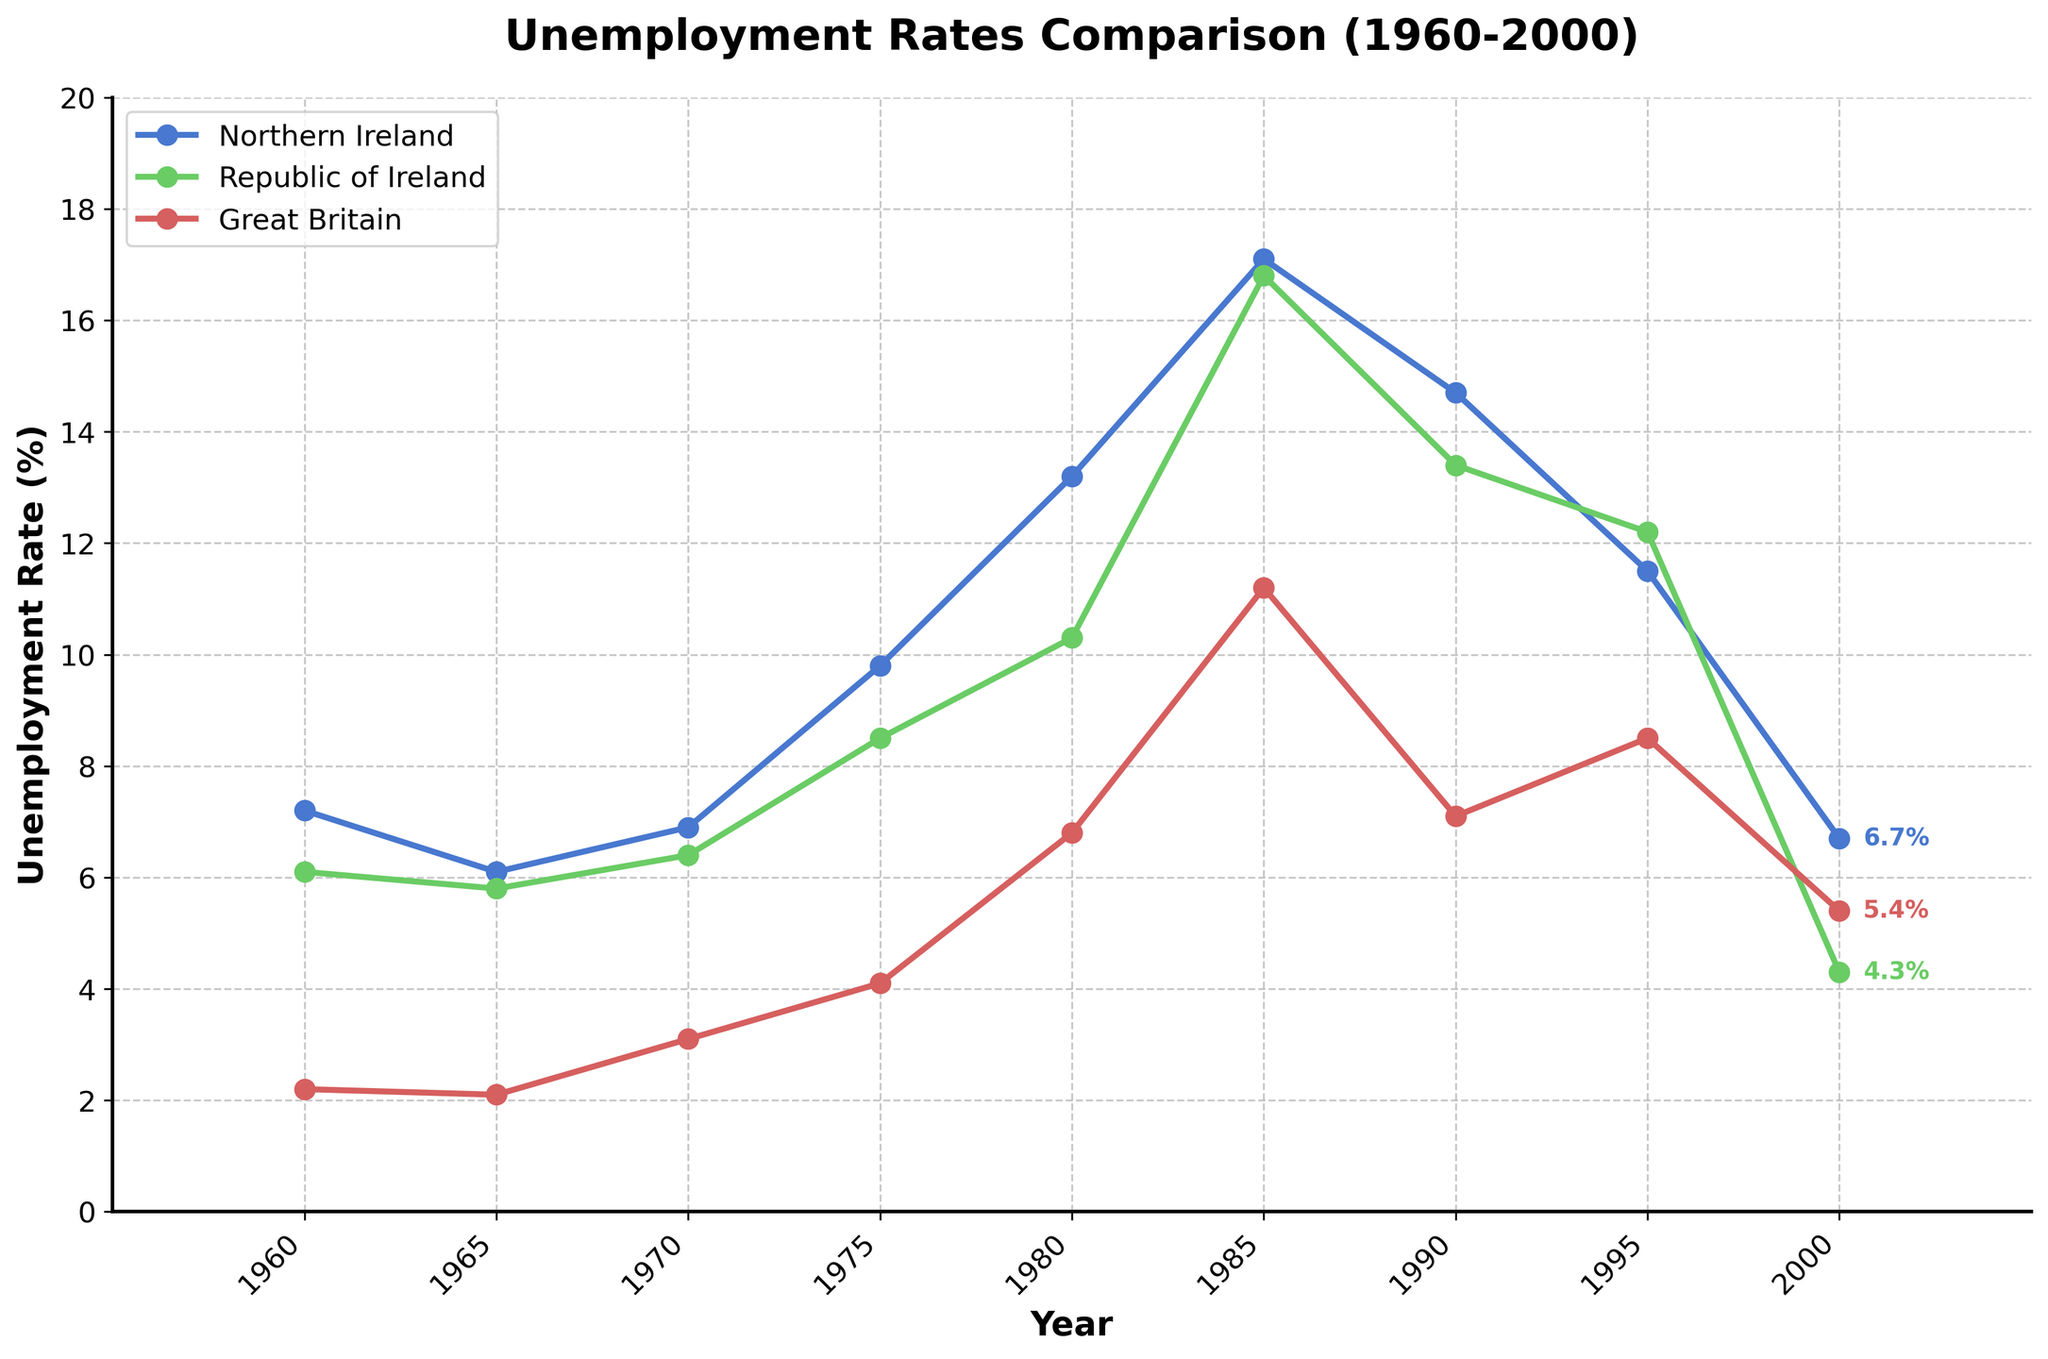What year did Northern Ireland have the highest unemployment rate, and what was the rate? To find the highest unemployment rate for Northern Ireland, look at the maximum data point in the Northern Ireland line. The peak occurs in 1985 with a rate of 17.1%.
Answer: 1985, 17.1% Which region had the lowest unemployment rate in 1960, and what was the rate? Look at the 1960 data points for Northern Ireland, the Republic of Ireland, and Great Britain. Great Britain had the lowest rate at 2.2%.
Answer: Great Britain, 2.2% By how much did the unemployment rate in Northern Ireland change from 1985 to 2000? Subtract the 2000 unemployment rate from the 1985 rate for Northern Ireland: \(17.1 - 6.7 = 10.4\).
Answer: 10.4% During which decade did the Republic of Ireland experience the highest unemployment rate? Look at the trend line for the Republic of Ireland and find the decade with the maximum value. The highest rate is 16.8% in 1985, which falls within the 1980s.
Answer: 1980s Which region had a higher unemployment rate in 1980, Northern Ireland or the Republic of Ireland, and by how much? Compare the 1980 values for Northern Ireland (13.2%) and the Republic of Ireland (10.3%). The difference is \(13.2 - 10.3 = 2.9\). Northern Ireland had a higher rate by 2.9%.
Answer: Northern Ireland, 2.9% What is the average unemployment rate for Great Britain from 1960 to 2000? Sum the unemployment rates for Great Britain from 1960 to 2000 and divide by the number of data points: \((2.2 + 2.1 + 3.1 + 4.1 + 6.8 + 11.2 + 7.1 + 8.5 + 5.4) / 9 = 5.5\).
Answer: 5.5% In what year did the unemployment rate in the Republic of Ireland surpass Northern Ireland for the first time? Compare the yearly data points of Northern Ireland and the Republic of Ireland. The Republic of Ireland first surpasses Northern Ireland in 1970 with rates of 6.4% vs 6.9%.
Answer: 1970 How does the unemployment rate in Great Britain in 2000 compare to its rate in 1960? Compare the 2000 data point (5.4%) to the 1960 data point (2.2%) for Great Britain. The rate increased by \(5.4 - 2.2 = 3.2\).
Answer: 3.2% higher Which region had the most stable unemployment rate from 1960 to 2000? Evaluate the fluctuation in the trend lines. Great Britain's line is the least volatile with smaller variations, indicating more stability.
Answer: Great Britain 